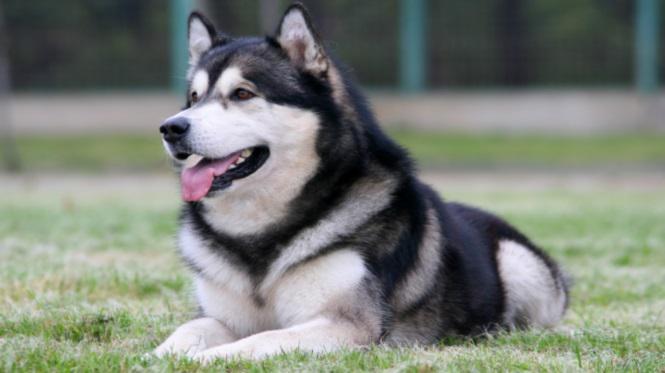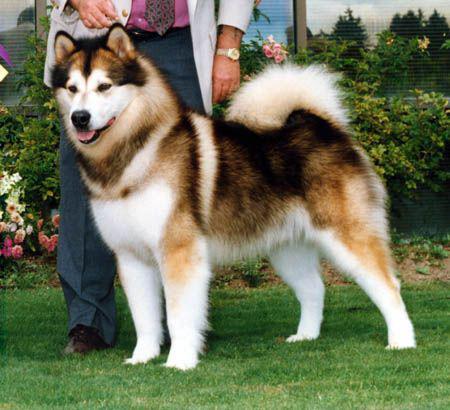The first image is the image on the left, the second image is the image on the right. Assess this claim about the two images: "The image on the right shows a left-facing dog standing in front of its owner.". Correct or not? Answer yes or no. Yes. The first image is the image on the left, the second image is the image on the right. Considering the images on both sides, is "All dogs are huskies with dark-and-white fur who are standing in profile, and the dogs on the left and right do not face the same [left or right] direction." valid? Answer yes or no. No. 